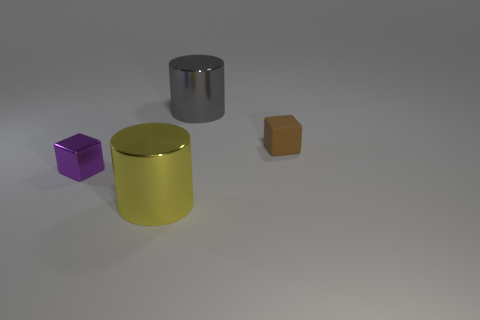Add 4 big metal things. How many objects exist? 8 Subtract 0 cyan balls. How many objects are left? 4 Subtract all small metallic cubes. Subtract all large gray metallic cylinders. How many objects are left? 2 Add 3 big gray cylinders. How many big gray cylinders are left? 4 Add 2 gray metal cylinders. How many gray metal cylinders exist? 3 